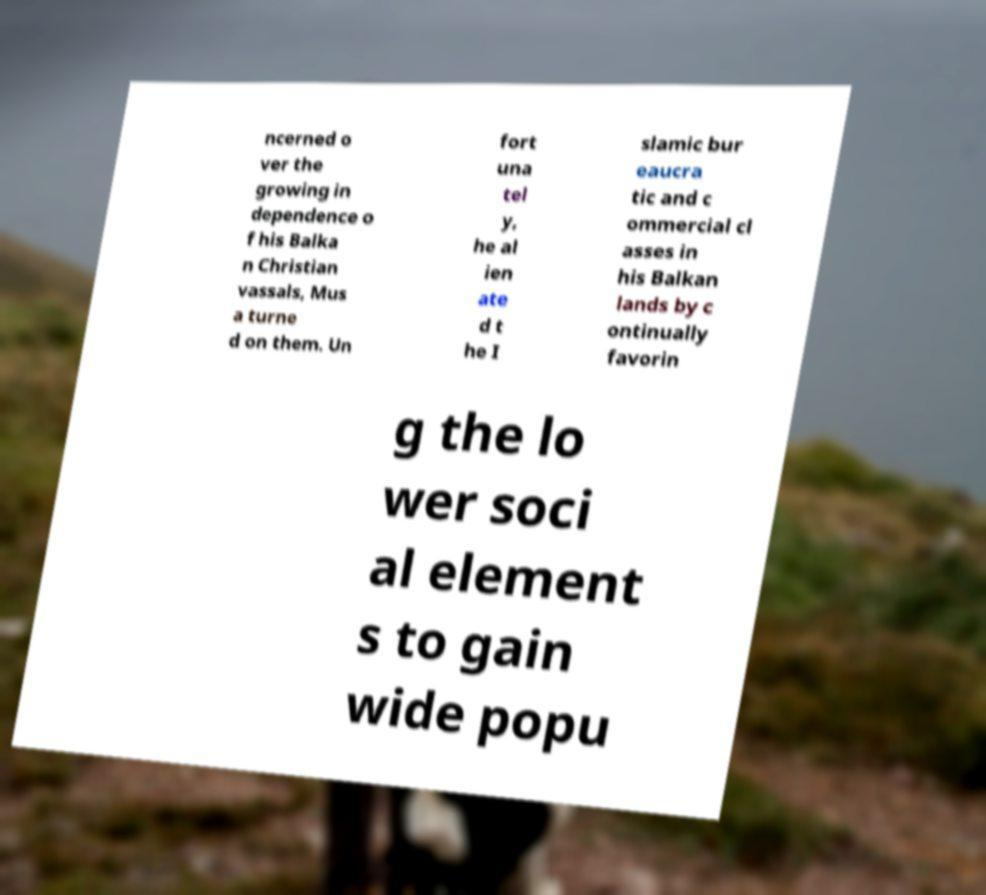Can you read and provide the text displayed in the image?This photo seems to have some interesting text. Can you extract and type it out for me? ncerned o ver the growing in dependence o f his Balka n Christian vassals, Mus a turne d on them. Un fort una tel y, he al ien ate d t he I slamic bur eaucra tic and c ommercial cl asses in his Balkan lands by c ontinually favorin g the lo wer soci al element s to gain wide popu 